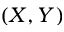<formula> <loc_0><loc_0><loc_500><loc_500>( X , Y )</formula> 